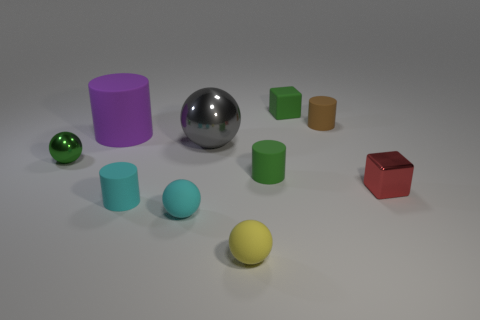Do the small matte object that is behind the tiny brown object and the small metal ball have the same color?
Keep it short and to the point. Yes. How many other things are the same shape as the big gray thing?
Your response must be concise. 3. How many other things are made of the same material as the red object?
Offer a very short reply. 2. What material is the tiny thing behind the cylinder on the right side of the tiny green rubber cube that is behind the big shiny object?
Your answer should be very brief. Rubber. Is the material of the cyan cylinder the same as the purple thing?
Give a very brief answer. Yes. What number of cylinders are either tiny green objects or large things?
Make the answer very short. 2. What is the color of the object on the left side of the big matte cylinder?
Your response must be concise. Green. What number of matte things are either big cylinders or tiny red cubes?
Keep it short and to the point. 1. There is a small yellow object that is in front of the cyan rubber object that is to the left of the small cyan sphere; what is its material?
Give a very brief answer. Rubber. There is a small ball that is the same color as the small rubber block; what is its material?
Provide a short and direct response. Metal. 